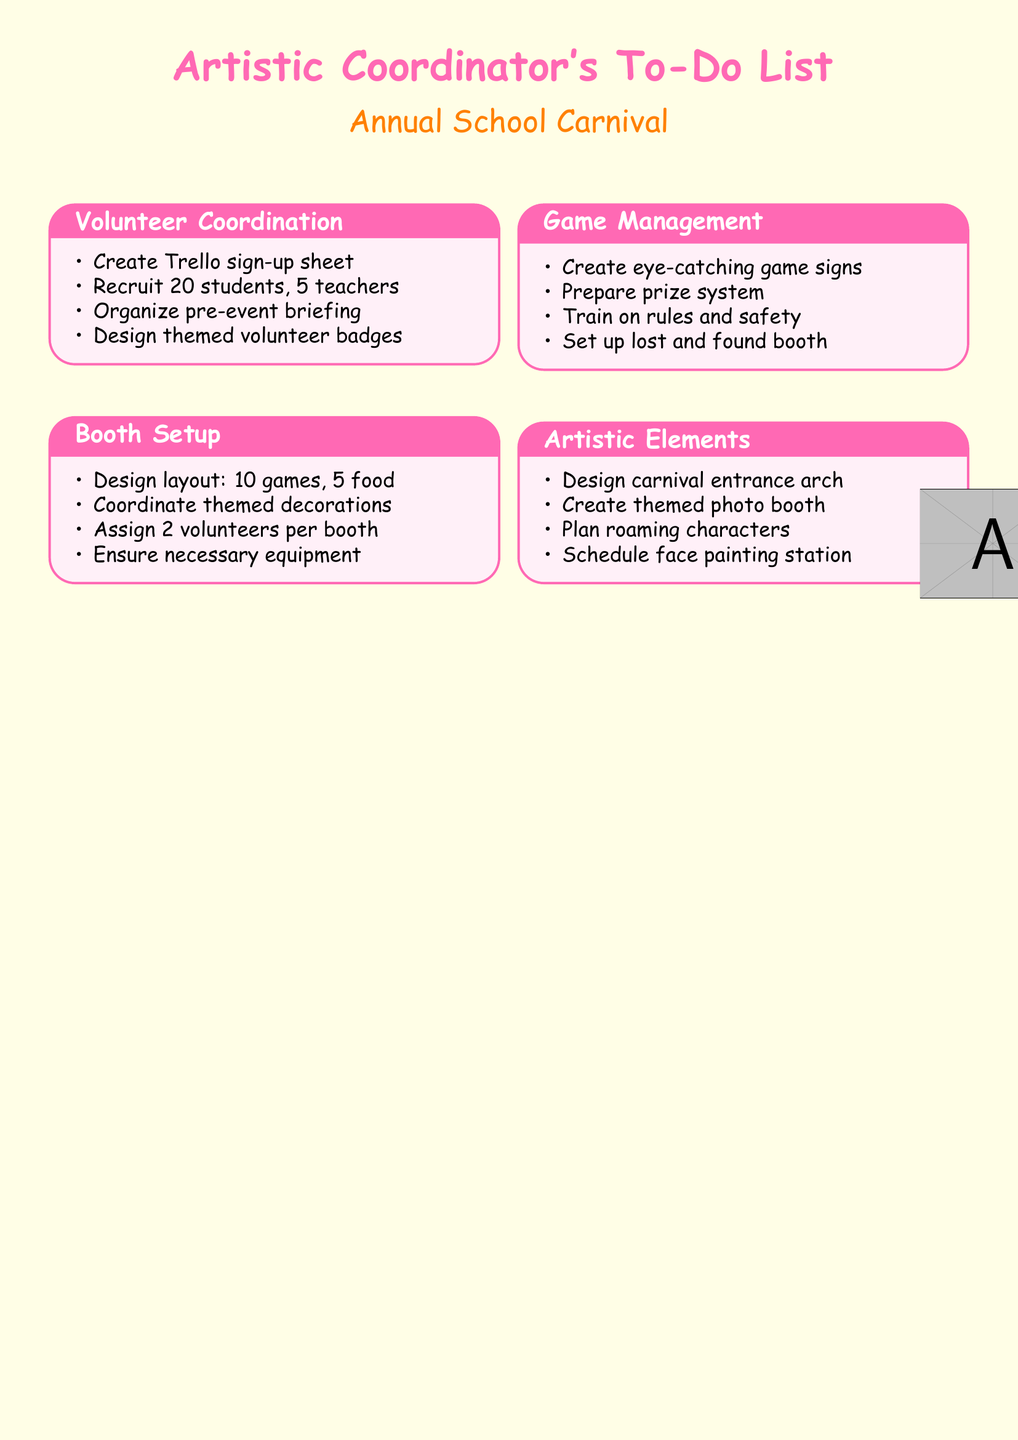What is the total number of student volunteers needed? The document states that 20 student volunteers are to be recruited for the event.
Answer: 20 How many teacher supervisors are required? According to the document, 5 teacher supervisors are needed for the carnival.
Answer: 5 What is one of the tasks listed under Game Management? The document mentions training volunteers on game rules and safety procedures as a task in Game Management.
Answer: Train volunteers How many game booths are planned? The document specifies a design layout for 10 game booths as part of the booth setup.
Answer: 10 What color is used in the document for the title text? The document uses a specific RGB color (255,105,180) for the title text and is referred to as carnival.
Answer: carnival Which group is coordinating the themed decorations for booths? The document states that the art club is coordinating the creation of themed decorations for each booth.
Answer: art club What item will be created for lost and found during the carnival? The central information booth is mentioned in the document as the setup for lost and found items.
Answer: central information booth What is designed as part of the artistic elements? The document lists a vibrant carnival entrance arch as one of the artistic elements to be designed.
Answer: carnival entrance arch How many volunteers are assigned per booth? The document specifies that 2 volunteers are to be assigned per booth for setup and management.
Answer: 2 